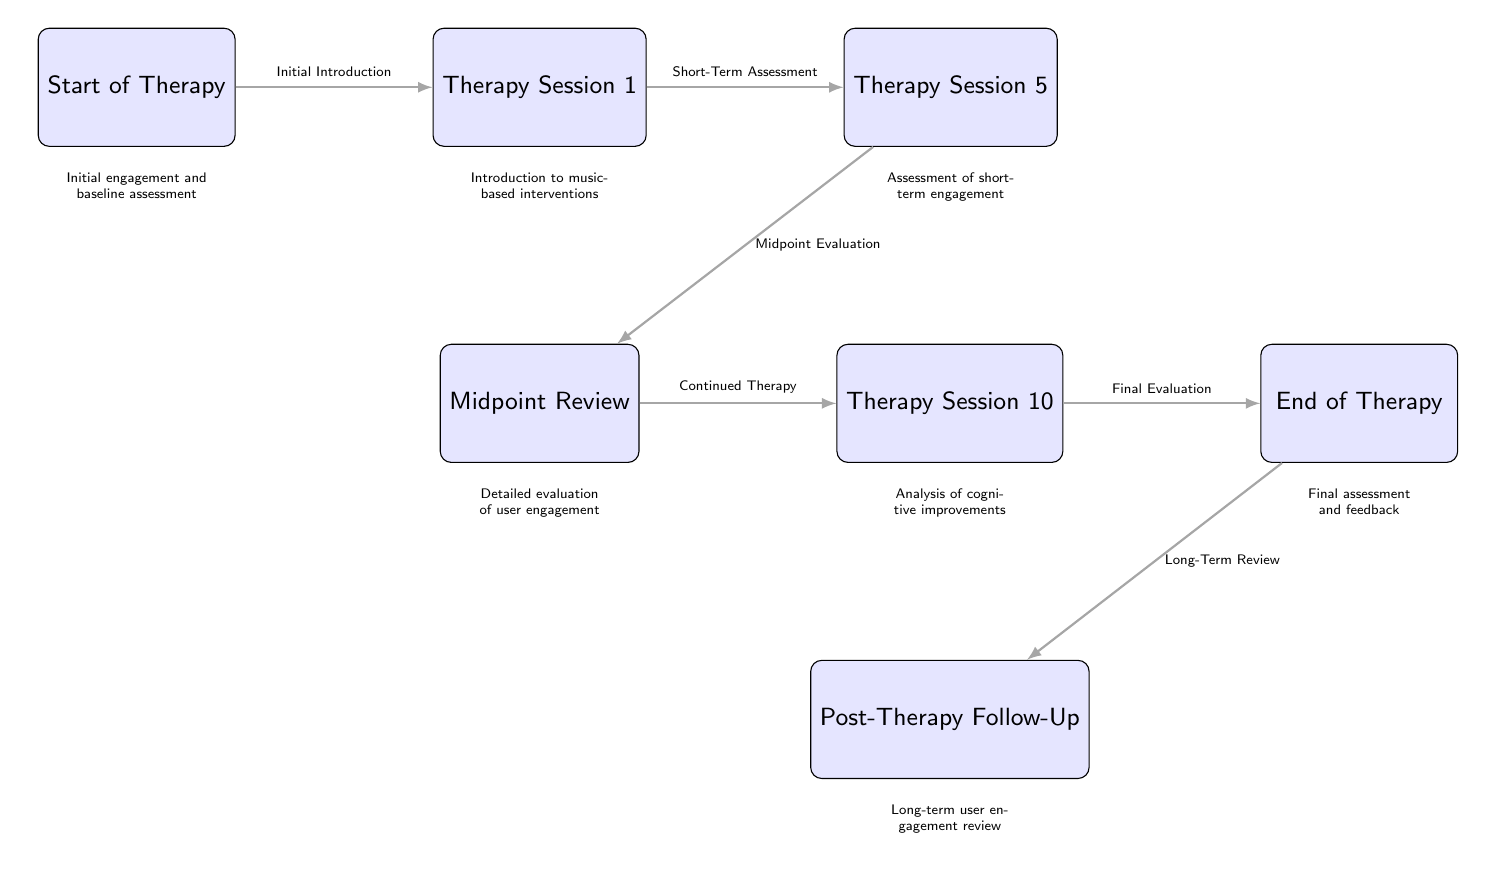What's the first node in the timeline? The first node in the timeline is labeled as "Start of Therapy," which is positioned at the beginning of the flow.
Answer: Start of Therapy How many therapy sessions are outlined in the diagram? By counting the nodes labeled as therapy sessions, there are five key sessions indicated (Therapy Session 1, Therapy Session 5, Therapy Session 10, Midpoint Review, and End of Therapy).
Answer: 5 What process is taking place between Therapy Session 1 and Therapy Session 5? The diagram indicates a "Short-Term Assessment" taking place between Therapy Session 1 and Therapy Session 5, suggesting that an evaluation occurs after the first session.
Answer: Short-Term Assessment What is the purpose of the Midpoint Review? The Midpoint Review serves as a "Detailed evaluation of user engagement," suggesting a comprehensive assessment at the halfway mark of the therapy.
Answer: Detailed evaluation of user engagement What follows the End of Therapy? Following the End of Therapy, the next step indicated is the "Post-Therapy Follow-Up," which suggests an assessment of the therapy’s impact after completion.
Answer: Post-Therapy Follow-Up Which evaluation occurs after Therapy Session 10? The next evaluation occurring after Therapy Session 10 is the "Final Evaluation," which is an assessment meant to review the outcomes at the conclusion of the therapy.
Answer: Final Evaluation What is the relationship between Therapy Session 5 and End of Therapy? The relationship is characterized by "Final Evaluation," indicating a critical assessment of user engagement and outcomes leading to the termination of the therapy.
Answer: Final Evaluation What step is taken immediately after the Midpoint Review? Immediately following the Midpoint Review is the step labeled as "Therapy Session 10," indicating the continuity of therapy following an evaluation phase.
Answer: Therapy Session 10 